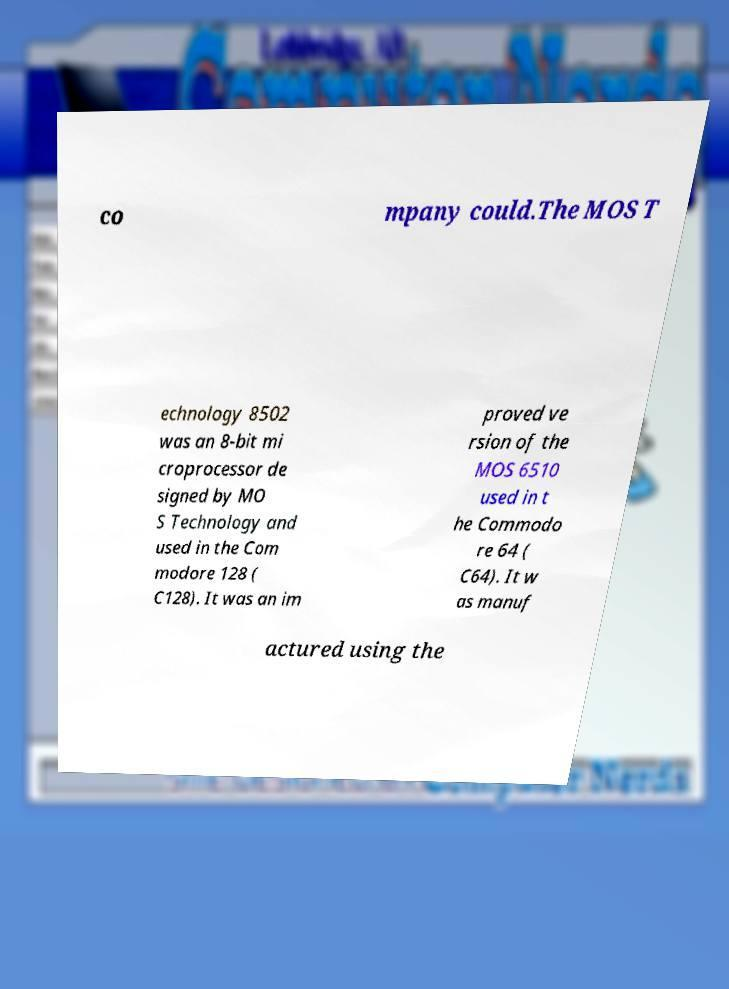Can you accurately transcribe the text from the provided image for me? co mpany could.The MOS T echnology 8502 was an 8-bit mi croprocessor de signed by MO S Technology and used in the Com modore 128 ( C128). It was an im proved ve rsion of the MOS 6510 used in t he Commodo re 64 ( C64). It w as manuf actured using the 